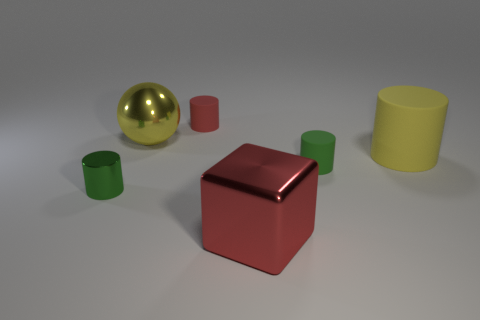What material is the yellow object that is the same shape as the tiny red matte object?
Offer a terse response. Rubber. There is a matte object behind the yellow rubber object; is its size the same as the big red shiny object?
Your answer should be very brief. No. How many matte objects are either large yellow spheres or tiny cylinders?
Offer a very short reply. 2. What is the material of the large object that is behind the small green shiny object and right of the small red matte thing?
Keep it short and to the point. Rubber. Do the sphere and the yellow cylinder have the same material?
Your answer should be very brief. No. What is the size of the cylinder that is both to the left of the green rubber cylinder and in front of the tiny red cylinder?
Offer a very short reply. Small. What is the shape of the yellow metallic object?
Ensure brevity in your answer.  Sphere. How many things are either yellow things or matte cylinders that are behind the small green rubber cylinder?
Provide a short and direct response. 3. Does the shiny thing behind the green metallic cylinder have the same color as the large shiny cube?
Give a very brief answer. No. What color is the shiny thing that is both in front of the small green matte cylinder and to the left of the red block?
Offer a terse response. Green. 